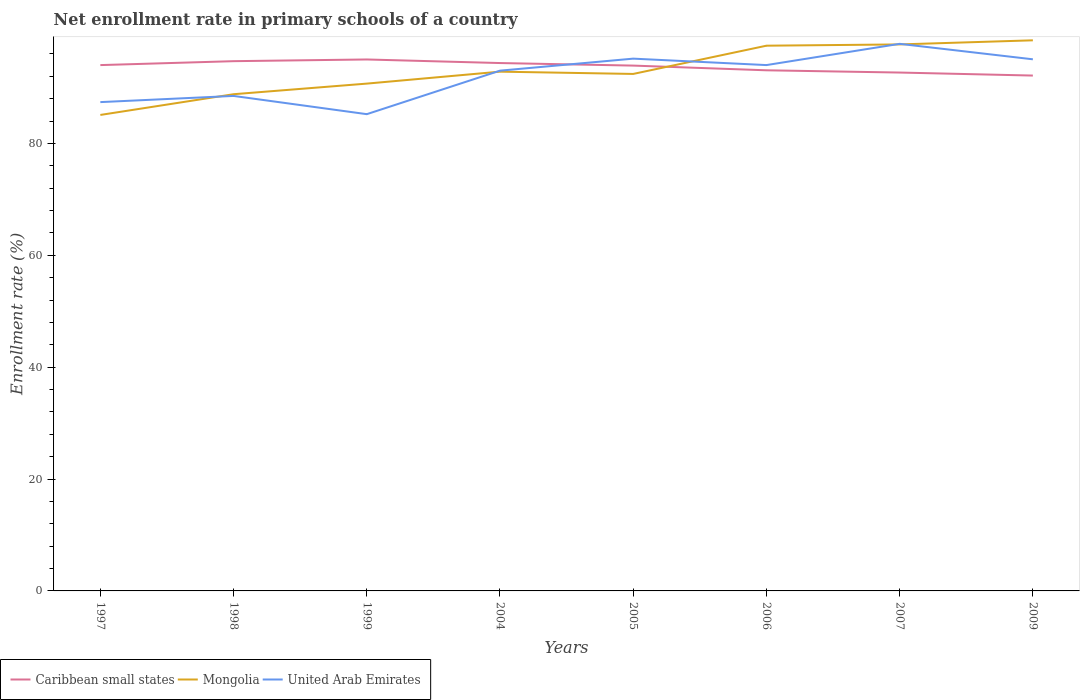How many different coloured lines are there?
Your answer should be very brief. 3. Is the number of lines equal to the number of legend labels?
Your response must be concise. Yes. Across all years, what is the maximum enrollment rate in primary schools in United Arab Emirates?
Provide a short and direct response. 85.24. What is the total enrollment rate in primary schools in Caribbean small states in the graph?
Offer a very short reply. 0.46. What is the difference between the highest and the second highest enrollment rate in primary schools in Mongolia?
Ensure brevity in your answer.  13.34. How many lines are there?
Your response must be concise. 3. How many years are there in the graph?
Offer a terse response. 8. Does the graph contain any zero values?
Your answer should be very brief. No. Does the graph contain grids?
Make the answer very short. No. How many legend labels are there?
Keep it short and to the point. 3. How are the legend labels stacked?
Give a very brief answer. Horizontal. What is the title of the graph?
Your answer should be compact. Net enrollment rate in primary schools of a country. What is the label or title of the Y-axis?
Your answer should be very brief. Enrollment rate (%). What is the Enrollment rate (%) of Caribbean small states in 1997?
Your response must be concise. 94.02. What is the Enrollment rate (%) in Mongolia in 1997?
Your answer should be compact. 85.1. What is the Enrollment rate (%) in United Arab Emirates in 1997?
Make the answer very short. 87.4. What is the Enrollment rate (%) in Caribbean small states in 1998?
Provide a succinct answer. 94.72. What is the Enrollment rate (%) in Mongolia in 1998?
Offer a terse response. 88.81. What is the Enrollment rate (%) of United Arab Emirates in 1998?
Give a very brief answer. 88.5. What is the Enrollment rate (%) in Caribbean small states in 1999?
Provide a succinct answer. 95.02. What is the Enrollment rate (%) of Mongolia in 1999?
Provide a short and direct response. 90.71. What is the Enrollment rate (%) in United Arab Emirates in 1999?
Keep it short and to the point. 85.24. What is the Enrollment rate (%) in Caribbean small states in 2004?
Offer a very short reply. 94.38. What is the Enrollment rate (%) in Mongolia in 2004?
Your response must be concise. 92.84. What is the Enrollment rate (%) of United Arab Emirates in 2004?
Ensure brevity in your answer.  93.02. What is the Enrollment rate (%) of Caribbean small states in 2005?
Your response must be concise. 93.93. What is the Enrollment rate (%) of Mongolia in 2005?
Provide a succinct answer. 92.44. What is the Enrollment rate (%) of United Arab Emirates in 2005?
Provide a succinct answer. 95.17. What is the Enrollment rate (%) of Caribbean small states in 2006?
Provide a short and direct response. 93.09. What is the Enrollment rate (%) in Mongolia in 2006?
Give a very brief answer. 97.49. What is the Enrollment rate (%) of United Arab Emirates in 2006?
Provide a short and direct response. 94.02. What is the Enrollment rate (%) in Caribbean small states in 2007?
Offer a terse response. 92.68. What is the Enrollment rate (%) of Mongolia in 2007?
Offer a terse response. 97.71. What is the Enrollment rate (%) of United Arab Emirates in 2007?
Ensure brevity in your answer.  97.82. What is the Enrollment rate (%) in Caribbean small states in 2009?
Make the answer very short. 92.14. What is the Enrollment rate (%) in Mongolia in 2009?
Make the answer very short. 98.45. What is the Enrollment rate (%) in United Arab Emirates in 2009?
Keep it short and to the point. 95.05. Across all years, what is the maximum Enrollment rate (%) in Caribbean small states?
Your answer should be compact. 95.02. Across all years, what is the maximum Enrollment rate (%) of Mongolia?
Keep it short and to the point. 98.45. Across all years, what is the maximum Enrollment rate (%) in United Arab Emirates?
Provide a succinct answer. 97.82. Across all years, what is the minimum Enrollment rate (%) of Caribbean small states?
Provide a succinct answer. 92.14. Across all years, what is the minimum Enrollment rate (%) in Mongolia?
Provide a short and direct response. 85.1. Across all years, what is the minimum Enrollment rate (%) in United Arab Emirates?
Provide a succinct answer. 85.24. What is the total Enrollment rate (%) of Caribbean small states in the graph?
Provide a short and direct response. 749.98. What is the total Enrollment rate (%) in Mongolia in the graph?
Your response must be concise. 743.54. What is the total Enrollment rate (%) in United Arab Emirates in the graph?
Make the answer very short. 736.22. What is the difference between the Enrollment rate (%) in Caribbean small states in 1997 and that in 1998?
Your answer should be very brief. -0.7. What is the difference between the Enrollment rate (%) of Mongolia in 1997 and that in 1998?
Your response must be concise. -3.71. What is the difference between the Enrollment rate (%) in United Arab Emirates in 1997 and that in 1998?
Your answer should be very brief. -1.11. What is the difference between the Enrollment rate (%) of Caribbean small states in 1997 and that in 1999?
Your answer should be very brief. -1. What is the difference between the Enrollment rate (%) in Mongolia in 1997 and that in 1999?
Make the answer very short. -5.6. What is the difference between the Enrollment rate (%) in United Arab Emirates in 1997 and that in 1999?
Provide a succinct answer. 2.16. What is the difference between the Enrollment rate (%) in Caribbean small states in 1997 and that in 2004?
Provide a succinct answer. -0.37. What is the difference between the Enrollment rate (%) in Mongolia in 1997 and that in 2004?
Offer a terse response. -7.74. What is the difference between the Enrollment rate (%) in United Arab Emirates in 1997 and that in 2004?
Your answer should be very brief. -5.62. What is the difference between the Enrollment rate (%) in Caribbean small states in 1997 and that in 2005?
Offer a very short reply. 0.09. What is the difference between the Enrollment rate (%) in Mongolia in 1997 and that in 2005?
Keep it short and to the point. -7.33. What is the difference between the Enrollment rate (%) of United Arab Emirates in 1997 and that in 2005?
Your answer should be compact. -7.77. What is the difference between the Enrollment rate (%) of Caribbean small states in 1997 and that in 2006?
Your answer should be compact. 0.93. What is the difference between the Enrollment rate (%) in Mongolia in 1997 and that in 2006?
Your answer should be compact. -12.38. What is the difference between the Enrollment rate (%) of United Arab Emirates in 1997 and that in 2006?
Give a very brief answer. -6.62. What is the difference between the Enrollment rate (%) in Caribbean small states in 1997 and that in 2007?
Provide a succinct answer. 1.33. What is the difference between the Enrollment rate (%) of Mongolia in 1997 and that in 2007?
Make the answer very short. -12.61. What is the difference between the Enrollment rate (%) of United Arab Emirates in 1997 and that in 2007?
Keep it short and to the point. -10.42. What is the difference between the Enrollment rate (%) of Caribbean small states in 1997 and that in 2009?
Provide a succinct answer. 1.87. What is the difference between the Enrollment rate (%) in Mongolia in 1997 and that in 2009?
Ensure brevity in your answer.  -13.34. What is the difference between the Enrollment rate (%) in United Arab Emirates in 1997 and that in 2009?
Give a very brief answer. -7.65. What is the difference between the Enrollment rate (%) in Caribbean small states in 1998 and that in 1999?
Your answer should be very brief. -0.3. What is the difference between the Enrollment rate (%) in Mongolia in 1998 and that in 1999?
Offer a very short reply. -1.9. What is the difference between the Enrollment rate (%) in United Arab Emirates in 1998 and that in 1999?
Ensure brevity in your answer.  3.26. What is the difference between the Enrollment rate (%) in Caribbean small states in 1998 and that in 2004?
Provide a succinct answer. 0.34. What is the difference between the Enrollment rate (%) in Mongolia in 1998 and that in 2004?
Ensure brevity in your answer.  -4.03. What is the difference between the Enrollment rate (%) of United Arab Emirates in 1998 and that in 2004?
Keep it short and to the point. -4.52. What is the difference between the Enrollment rate (%) in Caribbean small states in 1998 and that in 2005?
Your answer should be very brief. 0.79. What is the difference between the Enrollment rate (%) of Mongolia in 1998 and that in 2005?
Your answer should be very brief. -3.63. What is the difference between the Enrollment rate (%) of United Arab Emirates in 1998 and that in 2005?
Your response must be concise. -6.67. What is the difference between the Enrollment rate (%) of Caribbean small states in 1998 and that in 2006?
Provide a succinct answer. 1.63. What is the difference between the Enrollment rate (%) in Mongolia in 1998 and that in 2006?
Keep it short and to the point. -8.68. What is the difference between the Enrollment rate (%) in United Arab Emirates in 1998 and that in 2006?
Ensure brevity in your answer.  -5.52. What is the difference between the Enrollment rate (%) of Caribbean small states in 1998 and that in 2007?
Your response must be concise. 2.04. What is the difference between the Enrollment rate (%) of Mongolia in 1998 and that in 2007?
Make the answer very short. -8.9. What is the difference between the Enrollment rate (%) in United Arab Emirates in 1998 and that in 2007?
Keep it short and to the point. -9.31. What is the difference between the Enrollment rate (%) in Caribbean small states in 1998 and that in 2009?
Make the answer very short. 2.57. What is the difference between the Enrollment rate (%) of Mongolia in 1998 and that in 2009?
Offer a very short reply. -9.64. What is the difference between the Enrollment rate (%) in United Arab Emirates in 1998 and that in 2009?
Provide a succinct answer. -6.55. What is the difference between the Enrollment rate (%) in Caribbean small states in 1999 and that in 2004?
Offer a very short reply. 0.64. What is the difference between the Enrollment rate (%) of Mongolia in 1999 and that in 2004?
Your response must be concise. -2.14. What is the difference between the Enrollment rate (%) in United Arab Emirates in 1999 and that in 2004?
Give a very brief answer. -7.78. What is the difference between the Enrollment rate (%) in Caribbean small states in 1999 and that in 2005?
Offer a terse response. 1.1. What is the difference between the Enrollment rate (%) in Mongolia in 1999 and that in 2005?
Provide a short and direct response. -1.73. What is the difference between the Enrollment rate (%) in United Arab Emirates in 1999 and that in 2005?
Your answer should be very brief. -9.93. What is the difference between the Enrollment rate (%) in Caribbean small states in 1999 and that in 2006?
Provide a short and direct response. 1.94. What is the difference between the Enrollment rate (%) in Mongolia in 1999 and that in 2006?
Your response must be concise. -6.78. What is the difference between the Enrollment rate (%) of United Arab Emirates in 1999 and that in 2006?
Provide a succinct answer. -8.78. What is the difference between the Enrollment rate (%) of Caribbean small states in 1999 and that in 2007?
Give a very brief answer. 2.34. What is the difference between the Enrollment rate (%) in Mongolia in 1999 and that in 2007?
Your answer should be very brief. -7.01. What is the difference between the Enrollment rate (%) in United Arab Emirates in 1999 and that in 2007?
Your response must be concise. -12.58. What is the difference between the Enrollment rate (%) of Caribbean small states in 1999 and that in 2009?
Provide a succinct answer. 2.88. What is the difference between the Enrollment rate (%) in Mongolia in 1999 and that in 2009?
Make the answer very short. -7.74. What is the difference between the Enrollment rate (%) of United Arab Emirates in 1999 and that in 2009?
Ensure brevity in your answer.  -9.81. What is the difference between the Enrollment rate (%) in Caribbean small states in 2004 and that in 2005?
Offer a very short reply. 0.46. What is the difference between the Enrollment rate (%) in Mongolia in 2004 and that in 2005?
Offer a terse response. 0.41. What is the difference between the Enrollment rate (%) of United Arab Emirates in 2004 and that in 2005?
Your response must be concise. -2.15. What is the difference between the Enrollment rate (%) in Caribbean small states in 2004 and that in 2006?
Your answer should be very brief. 1.3. What is the difference between the Enrollment rate (%) in Mongolia in 2004 and that in 2006?
Provide a succinct answer. -4.64. What is the difference between the Enrollment rate (%) of United Arab Emirates in 2004 and that in 2006?
Your answer should be compact. -1. What is the difference between the Enrollment rate (%) of Caribbean small states in 2004 and that in 2007?
Ensure brevity in your answer.  1.7. What is the difference between the Enrollment rate (%) in Mongolia in 2004 and that in 2007?
Your answer should be very brief. -4.87. What is the difference between the Enrollment rate (%) in United Arab Emirates in 2004 and that in 2007?
Give a very brief answer. -4.8. What is the difference between the Enrollment rate (%) in Caribbean small states in 2004 and that in 2009?
Ensure brevity in your answer.  2.24. What is the difference between the Enrollment rate (%) in Mongolia in 2004 and that in 2009?
Make the answer very short. -5.6. What is the difference between the Enrollment rate (%) in United Arab Emirates in 2004 and that in 2009?
Keep it short and to the point. -2.03. What is the difference between the Enrollment rate (%) of Caribbean small states in 2005 and that in 2006?
Your answer should be compact. 0.84. What is the difference between the Enrollment rate (%) of Mongolia in 2005 and that in 2006?
Make the answer very short. -5.05. What is the difference between the Enrollment rate (%) in United Arab Emirates in 2005 and that in 2006?
Your answer should be very brief. 1.15. What is the difference between the Enrollment rate (%) in Caribbean small states in 2005 and that in 2007?
Your response must be concise. 1.24. What is the difference between the Enrollment rate (%) of Mongolia in 2005 and that in 2007?
Provide a short and direct response. -5.28. What is the difference between the Enrollment rate (%) in United Arab Emirates in 2005 and that in 2007?
Provide a short and direct response. -2.65. What is the difference between the Enrollment rate (%) of Caribbean small states in 2005 and that in 2009?
Your response must be concise. 1.78. What is the difference between the Enrollment rate (%) of Mongolia in 2005 and that in 2009?
Your answer should be compact. -6.01. What is the difference between the Enrollment rate (%) of United Arab Emirates in 2005 and that in 2009?
Ensure brevity in your answer.  0.12. What is the difference between the Enrollment rate (%) of Caribbean small states in 2006 and that in 2007?
Offer a terse response. 0.4. What is the difference between the Enrollment rate (%) of Mongolia in 2006 and that in 2007?
Offer a terse response. -0.23. What is the difference between the Enrollment rate (%) in United Arab Emirates in 2006 and that in 2007?
Make the answer very short. -3.8. What is the difference between the Enrollment rate (%) of Caribbean small states in 2006 and that in 2009?
Your answer should be compact. 0.94. What is the difference between the Enrollment rate (%) in Mongolia in 2006 and that in 2009?
Provide a succinct answer. -0.96. What is the difference between the Enrollment rate (%) in United Arab Emirates in 2006 and that in 2009?
Your answer should be compact. -1.03. What is the difference between the Enrollment rate (%) of Caribbean small states in 2007 and that in 2009?
Offer a terse response. 0.54. What is the difference between the Enrollment rate (%) of Mongolia in 2007 and that in 2009?
Provide a succinct answer. -0.73. What is the difference between the Enrollment rate (%) of United Arab Emirates in 2007 and that in 2009?
Your answer should be compact. 2.77. What is the difference between the Enrollment rate (%) in Caribbean small states in 1997 and the Enrollment rate (%) in Mongolia in 1998?
Provide a short and direct response. 5.21. What is the difference between the Enrollment rate (%) in Caribbean small states in 1997 and the Enrollment rate (%) in United Arab Emirates in 1998?
Make the answer very short. 5.51. What is the difference between the Enrollment rate (%) of Mongolia in 1997 and the Enrollment rate (%) of United Arab Emirates in 1998?
Provide a succinct answer. -3.4. What is the difference between the Enrollment rate (%) of Caribbean small states in 1997 and the Enrollment rate (%) of Mongolia in 1999?
Your response must be concise. 3.31. What is the difference between the Enrollment rate (%) of Caribbean small states in 1997 and the Enrollment rate (%) of United Arab Emirates in 1999?
Your answer should be very brief. 8.77. What is the difference between the Enrollment rate (%) in Mongolia in 1997 and the Enrollment rate (%) in United Arab Emirates in 1999?
Ensure brevity in your answer.  -0.14. What is the difference between the Enrollment rate (%) of Caribbean small states in 1997 and the Enrollment rate (%) of Mongolia in 2004?
Keep it short and to the point. 1.17. What is the difference between the Enrollment rate (%) of Mongolia in 1997 and the Enrollment rate (%) of United Arab Emirates in 2004?
Your response must be concise. -7.92. What is the difference between the Enrollment rate (%) in Caribbean small states in 1997 and the Enrollment rate (%) in Mongolia in 2005?
Ensure brevity in your answer.  1.58. What is the difference between the Enrollment rate (%) of Caribbean small states in 1997 and the Enrollment rate (%) of United Arab Emirates in 2005?
Provide a succinct answer. -1.15. What is the difference between the Enrollment rate (%) of Mongolia in 1997 and the Enrollment rate (%) of United Arab Emirates in 2005?
Give a very brief answer. -10.07. What is the difference between the Enrollment rate (%) in Caribbean small states in 1997 and the Enrollment rate (%) in Mongolia in 2006?
Your answer should be compact. -3.47. What is the difference between the Enrollment rate (%) of Caribbean small states in 1997 and the Enrollment rate (%) of United Arab Emirates in 2006?
Ensure brevity in your answer.  -0. What is the difference between the Enrollment rate (%) of Mongolia in 1997 and the Enrollment rate (%) of United Arab Emirates in 2006?
Your answer should be compact. -8.92. What is the difference between the Enrollment rate (%) in Caribbean small states in 1997 and the Enrollment rate (%) in Mongolia in 2007?
Offer a terse response. -3.7. What is the difference between the Enrollment rate (%) in Caribbean small states in 1997 and the Enrollment rate (%) in United Arab Emirates in 2007?
Your answer should be very brief. -3.8. What is the difference between the Enrollment rate (%) in Mongolia in 1997 and the Enrollment rate (%) in United Arab Emirates in 2007?
Give a very brief answer. -12.71. What is the difference between the Enrollment rate (%) in Caribbean small states in 1997 and the Enrollment rate (%) in Mongolia in 2009?
Provide a short and direct response. -4.43. What is the difference between the Enrollment rate (%) in Caribbean small states in 1997 and the Enrollment rate (%) in United Arab Emirates in 2009?
Ensure brevity in your answer.  -1.03. What is the difference between the Enrollment rate (%) in Mongolia in 1997 and the Enrollment rate (%) in United Arab Emirates in 2009?
Offer a terse response. -9.95. What is the difference between the Enrollment rate (%) in Caribbean small states in 1998 and the Enrollment rate (%) in Mongolia in 1999?
Ensure brevity in your answer.  4.01. What is the difference between the Enrollment rate (%) in Caribbean small states in 1998 and the Enrollment rate (%) in United Arab Emirates in 1999?
Make the answer very short. 9.48. What is the difference between the Enrollment rate (%) in Mongolia in 1998 and the Enrollment rate (%) in United Arab Emirates in 1999?
Ensure brevity in your answer.  3.57. What is the difference between the Enrollment rate (%) of Caribbean small states in 1998 and the Enrollment rate (%) of Mongolia in 2004?
Your response must be concise. 1.87. What is the difference between the Enrollment rate (%) of Caribbean small states in 1998 and the Enrollment rate (%) of United Arab Emirates in 2004?
Your answer should be compact. 1.7. What is the difference between the Enrollment rate (%) in Mongolia in 1998 and the Enrollment rate (%) in United Arab Emirates in 2004?
Your answer should be very brief. -4.21. What is the difference between the Enrollment rate (%) in Caribbean small states in 1998 and the Enrollment rate (%) in Mongolia in 2005?
Your response must be concise. 2.28. What is the difference between the Enrollment rate (%) in Caribbean small states in 1998 and the Enrollment rate (%) in United Arab Emirates in 2005?
Offer a very short reply. -0.45. What is the difference between the Enrollment rate (%) in Mongolia in 1998 and the Enrollment rate (%) in United Arab Emirates in 2005?
Offer a terse response. -6.36. What is the difference between the Enrollment rate (%) of Caribbean small states in 1998 and the Enrollment rate (%) of Mongolia in 2006?
Provide a short and direct response. -2.77. What is the difference between the Enrollment rate (%) in Caribbean small states in 1998 and the Enrollment rate (%) in United Arab Emirates in 2006?
Provide a succinct answer. 0.7. What is the difference between the Enrollment rate (%) of Mongolia in 1998 and the Enrollment rate (%) of United Arab Emirates in 2006?
Provide a short and direct response. -5.21. What is the difference between the Enrollment rate (%) of Caribbean small states in 1998 and the Enrollment rate (%) of Mongolia in 2007?
Ensure brevity in your answer.  -2.99. What is the difference between the Enrollment rate (%) of Caribbean small states in 1998 and the Enrollment rate (%) of United Arab Emirates in 2007?
Keep it short and to the point. -3.1. What is the difference between the Enrollment rate (%) in Mongolia in 1998 and the Enrollment rate (%) in United Arab Emirates in 2007?
Offer a terse response. -9.01. What is the difference between the Enrollment rate (%) of Caribbean small states in 1998 and the Enrollment rate (%) of Mongolia in 2009?
Your response must be concise. -3.73. What is the difference between the Enrollment rate (%) of Caribbean small states in 1998 and the Enrollment rate (%) of United Arab Emirates in 2009?
Offer a terse response. -0.33. What is the difference between the Enrollment rate (%) of Mongolia in 1998 and the Enrollment rate (%) of United Arab Emirates in 2009?
Offer a very short reply. -6.24. What is the difference between the Enrollment rate (%) of Caribbean small states in 1999 and the Enrollment rate (%) of Mongolia in 2004?
Keep it short and to the point. 2.18. What is the difference between the Enrollment rate (%) in Caribbean small states in 1999 and the Enrollment rate (%) in United Arab Emirates in 2004?
Make the answer very short. 2. What is the difference between the Enrollment rate (%) in Mongolia in 1999 and the Enrollment rate (%) in United Arab Emirates in 2004?
Give a very brief answer. -2.32. What is the difference between the Enrollment rate (%) of Caribbean small states in 1999 and the Enrollment rate (%) of Mongolia in 2005?
Make the answer very short. 2.59. What is the difference between the Enrollment rate (%) of Caribbean small states in 1999 and the Enrollment rate (%) of United Arab Emirates in 2005?
Your response must be concise. -0.15. What is the difference between the Enrollment rate (%) of Mongolia in 1999 and the Enrollment rate (%) of United Arab Emirates in 2005?
Offer a very short reply. -4.46. What is the difference between the Enrollment rate (%) in Caribbean small states in 1999 and the Enrollment rate (%) in Mongolia in 2006?
Give a very brief answer. -2.46. What is the difference between the Enrollment rate (%) of Mongolia in 1999 and the Enrollment rate (%) of United Arab Emirates in 2006?
Offer a terse response. -3.31. What is the difference between the Enrollment rate (%) in Caribbean small states in 1999 and the Enrollment rate (%) in Mongolia in 2007?
Ensure brevity in your answer.  -2.69. What is the difference between the Enrollment rate (%) of Caribbean small states in 1999 and the Enrollment rate (%) of United Arab Emirates in 2007?
Ensure brevity in your answer.  -2.8. What is the difference between the Enrollment rate (%) of Mongolia in 1999 and the Enrollment rate (%) of United Arab Emirates in 2007?
Your answer should be very brief. -7.11. What is the difference between the Enrollment rate (%) in Caribbean small states in 1999 and the Enrollment rate (%) in Mongolia in 2009?
Your answer should be compact. -3.43. What is the difference between the Enrollment rate (%) in Caribbean small states in 1999 and the Enrollment rate (%) in United Arab Emirates in 2009?
Offer a terse response. -0.03. What is the difference between the Enrollment rate (%) in Mongolia in 1999 and the Enrollment rate (%) in United Arab Emirates in 2009?
Give a very brief answer. -4.34. What is the difference between the Enrollment rate (%) in Caribbean small states in 2004 and the Enrollment rate (%) in Mongolia in 2005?
Your response must be concise. 1.95. What is the difference between the Enrollment rate (%) of Caribbean small states in 2004 and the Enrollment rate (%) of United Arab Emirates in 2005?
Make the answer very short. -0.79. What is the difference between the Enrollment rate (%) of Mongolia in 2004 and the Enrollment rate (%) of United Arab Emirates in 2005?
Your answer should be compact. -2.33. What is the difference between the Enrollment rate (%) of Caribbean small states in 2004 and the Enrollment rate (%) of Mongolia in 2006?
Offer a terse response. -3.1. What is the difference between the Enrollment rate (%) in Caribbean small states in 2004 and the Enrollment rate (%) in United Arab Emirates in 2006?
Your response must be concise. 0.36. What is the difference between the Enrollment rate (%) in Mongolia in 2004 and the Enrollment rate (%) in United Arab Emirates in 2006?
Your answer should be compact. -1.18. What is the difference between the Enrollment rate (%) of Caribbean small states in 2004 and the Enrollment rate (%) of Mongolia in 2007?
Offer a terse response. -3.33. What is the difference between the Enrollment rate (%) in Caribbean small states in 2004 and the Enrollment rate (%) in United Arab Emirates in 2007?
Your answer should be compact. -3.43. What is the difference between the Enrollment rate (%) of Mongolia in 2004 and the Enrollment rate (%) of United Arab Emirates in 2007?
Provide a succinct answer. -4.97. What is the difference between the Enrollment rate (%) in Caribbean small states in 2004 and the Enrollment rate (%) in Mongolia in 2009?
Your response must be concise. -4.07. What is the difference between the Enrollment rate (%) of Caribbean small states in 2004 and the Enrollment rate (%) of United Arab Emirates in 2009?
Your answer should be compact. -0.67. What is the difference between the Enrollment rate (%) in Mongolia in 2004 and the Enrollment rate (%) in United Arab Emirates in 2009?
Your response must be concise. -2.21. What is the difference between the Enrollment rate (%) in Caribbean small states in 2005 and the Enrollment rate (%) in Mongolia in 2006?
Keep it short and to the point. -3.56. What is the difference between the Enrollment rate (%) of Caribbean small states in 2005 and the Enrollment rate (%) of United Arab Emirates in 2006?
Make the answer very short. -0.09. What is the difference between the Enrollment rate (%) of Mongolia in 2005 and the Enrollment rate (%) of United Arab Emirates in 2006?
Give a very brief answer. -1.58. What is the difference between the Enrollment rate (%) in Caribbean small states in 2005 and the Enrollment rate (%) in Mongolia in 2007?
Offer a terse response. -3.79. What is the difference between the Enrollment rate (%) of Caribbean small states in 2005 and the Enrollment rate (%) of United Arab Emirates in 2007?
Give a very brief answer. -3.89. What is the difference between the Enrollment rate (%) in Mongolia in 2005 and the Enrollment rate (%) in United Arab Emirates in 2007?
Offer a very short reply. -5.38. What is the difference between the Enrollment rate (%) of Caribbean small states in 2005 and the Enrollment rate (%) of Mongolia in 2009?
Provide a short and direct response. -4.52. What is the difference between the Enrollment rate (%) in Caribbean small states in 2005 and the Enrollment rate (%) in United Arab Emirates in 2009?
Your answer should be compact. -1.12. What is the difference between the Enrollment rate (%) of Mongolia in 2005 and the Enrollment rate (%) of United Arab Emirates in 2009?
Provide a succinct answer. -2.61. What is the difference between the Enrollment rate (%) of Caribbean small states in 2006 and the Enrollment rate (%) of Mongolia in 2007?
Your answer should be compact. -4.63. What is the difference between the Enrollment rate (%) in Caribbean small states in 2006 and the Enrollment rate (%) in United Arab Emirates in 2007?
Your answer should be very brief. -4.73. What is the difference between the Enrollment rate (%) in Mongolia in 2006 and the Enrollment rate (%) in United Arab Emirates in 2007?
Provide a short and direct response. -0.33. What is the difference between the Enrollment rate (%) of Caribbean small states in 2006 and the Enrollment rate (%) of Mongolia in 2009?
Make the answer very short. -5.36. What is the difference between the Enrollment rate (%) in Caribbean small states in 2006 and the Enrollment rate (%) in United Arab Emirates in 2009?
Offer a very short reply. -1.96. What is the difference between the Enrollment rate (%) in Mongolia in 2006 and the Enrollment rate (%) in United Arab Emirates in 2009?
Ensure brevity in your answer.  2.44. What is the difference between the Enrollment rate (%) in Caribbean small states in 2007 and the Enrollment rate (%) in Mongolia in 2009?
Give a very brief answer. -5.77. What is the difference between the Enrollment rate (%) of Caribbean small states in 2007 and the Enrollment rate (%) of United Arab Emirates in 2009?
Provide a short and direct response. -2.37. What is the difference between the Enrollment rate (%) of Mongolia in 2007 and the Enrollment rate (%) of United Arab Emirates in 2009?
Keep it short and to the point. 2.66. What is the average Enrollment rate (%) in Caribbean small states per year?
Give a very brief answer. 93.75. What is the average Enrollment rate (%) in Mongolia per year?
Provide a succinct answer. 92.94. What is the average Enrollment rate (%) of United Arab Emirates per year?
Your response must be concise. 92.03. In the year 1997, what is the difference between the Enrollment rate (%) of Caribbean small states and Enrollment rate (%) of Mongolia?
Your response must be concise. 8.91. In the year 1997, what is the difference between the Enrollment rate (%) in Caribbean small states and Enrollment rate (%) in United Arab Emirates?
Provide a succinct answer. 6.62. In the year 1997, what is the difference between the Enrollment rate (%) of Mongolia and Enrollment rate (%) of United Arab Emirates?
Ensure brevity in your answer.  -2.29. In the year 1998, what is the difference between the Enrollment rate (%) of Caribbean small states and Enrollment rate (%) of Mongolia?
Your answer should be compact. 5.91. In the year 1998, what is the difference between the Enrollment rate (%) in Caribbean small states and Enrollment rate (%) in United Arab Emirates?
Your answer should be compact. 6.21. In the year 1998, what is the difference between the Enrollment rate (%) of Mongolia and Enrollment rate (%) of United Arab Emirates?
Keep it short and to the point. 0.3. In the year 1999, what is the difference between the Enrollment rate (%) of Caribbean small states and Enrollment rate (%) of Mongolia?
Make the answer very short. 4.32. In the year 1999, what is the difference between the Enrollment rate (%) of Caribbean small states and Enrollment rate (%) of United Arab Emirates?
Provide a succinct answer. 9.78. In the year 1999, what is the difference between the Enrollment rate (%) of Mongolia and Enrollment rate (%) of United Arab Emirates?
Your response must be concise. 5.46. In the year 2004, what is the difference between the Enrollment rate (%) of Caribbean small states and Enrollment rate (%) of Mongolia?
Provide a succinct answer. 1.54. In the year 2004, what is the difference between the Enrollment rate (%) in Caribbean small states and Enrollment rate (%) in United Arab Emirates?
Your response must be concise. 1.36. In the year 2004, what is the difference between the Enrollment rate (%) in Mongolia and Enrollment rate (%) in United Arab Emirates?
Ensure brevity in your answer.  -0.18. In the year 2005, what is the difference between the Enrollment rate (%) of Caribbean small states and Enrollment rate (%) of Mongolia?
Make the answer very short. 1.49. In the year 2005, what is the difference between the Enrollment rate (%) of Caribbean small states and Enrollment rate (%) of United Arab Emirates?
Your response must be concise. -1.24. In the year 2005, what is the difference between the Enrollment rate (%) in Mongolia and Enrollment rate (%) in United Arab Emirates?
Your answer should be compact. -2.73. In the year 2006, what is the difference between the Enrollment rate (%) of Caribbean small states and Enrollment rate (%) of Mongolia?
Give a very brief answer. -4.4. In the year 2006, what is the difference between the Enrollment rate (%) in Caribbean small states and Enrollment rate (%) in United Arab Emirates?
Make the answer very short. -0.93. In the year 2006, what is the difference between the Enrollment rate (%) of Mongolia and Enrollment rate (%) of United Arab Emirates?
Keep it short and to the point. 3.47. In the year 2007, what is the difference between the Enrollment rate (%) of Caribbean small states and Enrollment rate (%) of Mongolia?
Offer a very short reply. -5.03. In the year 2007, what is the difference between the Enrollment rate (%) in Caribbean small states and Enrollment rate (%) in United Arab Emirates?
Offer a terse response. -5.13. In the year 2007, what is the difference between the Enrollment rate (%) of Mongolia and Enrollment rate (%) of United Arab Emirates?
Make the answer very short. -0.1. In the year 2009, what is the difference between the Enrollment rate (%) of Caribbean small states and Enrollment rate (%) of Mongolia?
Provide a succinct answer. -6.3. In the year 2009, what is the difference between the Enrollment rate (%) of Caribbean small states and Enrollment rate (%) of United Arab Emirates?
Your answer should be very brief. -2.91. In the year 2009, what is the difference between the Enrollment rate (%) of Mongolia and Enrollment rate (%) of United Arab Emirates?
Your response must be concise. 3.4. What is the ratio of the Enrollment rate (%) of Mongolia in 1997 to that in 1998?
Your answer should be very brief. 0.96. What is the ratio of the Enrollment rate (%) in United Arab Emirates in 1997 to that in 1998?
Offer a terse response. 0.99. What is the ratio of the Enrollment rate (%) of Caribbean small states in 1997 to that in 1999?
Offer a terse response. 0.99. What is the ratio of the Enrollment rate (%) in Mongolia in 1997 to that in 1999?
Provide a succinct answer. 0.94. What is the ratio of the Enrollment rate (%) of United Arab Emirates in 1997 to that in 1999?
Provide a short and direct response. 1.03. What is the ratio of the Enrollment rate (%) in Mongolia in 1997 to that in 2004?
Your answer should be very brief. 0.92. What is the ratio of the Enrollment rate (%) of United Arab Emirates in 1997 to that in 2004?
Your response must be concise. 0.94. What is the ratio of the Enrollment rate (%) of Caribbean small states in 1997 to that in 2005?
Offer a terse response. 1. What is the ratio of the Enrollment rate (%) in Mongolia in 1997 to that in 2005?
Your response must be concise. 0.92. What is the ratio of the Enrollment rate (%) of United Arab Emirates in 1997 to that in 2005?
Make the answer very short. 0.92. What is the ratio of the Enrollment rate (%) in Mongolia in 1997 to that in 2006?
Your answer should be very brief. 0.87. What is the ratio of the Enrollment rate (%) of United Arab Emirates in 1997 to that in 2006?
Provide a succinct answer. 0.93. What is the ratio of the Enrollment rate (%) in Caribbean small states in 1997 to that in 2007?
Your answer should be very brief. 1.01. What is the ratio of the Enrollment rate (%) in Mongolia in 1997 to that in 2007?
Provide a short and direct response. 0.87. What is the ratio of the Enrollment rate (%) of United Arab Emirates in 1997 to that in 2007?
Provide a succinct answer. 0.89. What is the ratio of the Enrollment rate (%) in Caribbean small states in 1997 to that in 2009?
Keep it short and to the point. 1.02. What is the ratio of the Enrollment rate (%) in Mongolia in 1997 to that in 2009?
Your answer should be very brief. 0.86. What is the ratio of the Enrollment rate (%) of United Arab Emirates in 1997 to that in 2009?
Keep it short and to the point. 0.92. What is the ratio of the Enrollment rate (%) of Caribbean small states in 1998 to that in 1999?
Ensure brevity in your answer.  1. What is the ratio of the Enrollment rate (%) in Mongolia in 1998 to that in 1999?
Offer a very short reply. 0.98. What is the ratio of the Enrollment rate (%) of United Arab Emirates in 1998 to that in 1999?
Give a very brief answer. 1.04. What is the ratio of the Enrollment rate (%) in Mongolia in 1998 to that in 2004?
Ensure brevity in your answer.  0.96. What is the ratio of the Enrollment rate (%) in United Arab Emirates in 1998 to that in 2004?
Give a very brief answer. 0.95. What is the ratio of the Enrollment rate (%) in Caribbean small states in 1998 to that in 2005?
Offer a very short reply. 1.01. What is the ratio of the Enrollment rate (%) in Mongolia in 1998 to that in 2005?
Provide a succinct answer. 0.96. What is the ratio of the Enrollment rate (%) in Caribbean small states in 1998 to that in 2006?
Your answer should be very brief. 1.02. What is the ratio of the Enrollment rate (%) in Mongolia in 1998 to that in 2006?
Make the answer very short. 0.91. What is the ratio of the Enrollment rate (%) of United Arab Emirates in 1998 to that in 2006?
Offer a terse response. 0.94. What is the ratio of the Enrollment rate (%) of Mongolia in 1998 to that in 2007?
Provide a short and direct response. 0.91. What is the ratio of the Enrollment rate (%) in United Arab Emirates in 1998 to that in 2007?
Your response must be concise. 0.9. What is the ratio of the Enrollment rate (%) of Caribbean small states in 1998 to that in 2009?
Offer a very short reply. 1.03. What is the ratio of the Enrollment rate (%) of Mongolia in 1998 to that in 2009?
Make the answer very short. 0.9. What is the ratio of the Enrollment rate (%) of United Arab Emirates in 1998 to that in 2009?
Give a very brief answer. 0.93. What is the ratio of the Enrollment rate (%) of Caribbean small states in 1999 to that in 2004?
Your response must be concise. 1.01. What is the ratio of the Enrollment rate (%) of Mongolia in 1999 to that in 2004?
Your answer should be very brief. 0.98. What is the ratio of the Enrollment rate (%) in United Arab Emirates in 1999 to that in 2004?
Your answer should be very brief. 0.92. What is the ratio of the Enrollment rate (%) in Caribbean small states in 1999 to that in 2005?
Offer a very short reply. 1.01. What is the ratio of the Enrollment rate (%) of Mongolia in 1999 to that in 2005?
Make the answer very short. 0.98. What is the ratio of the Enrollment rate (%) of United Arab Emirates in 1999 to that in 2005?
Make the answer very short. 0.9. What is the ratio of the Enrollment rate (%) in Caribbean small states in 1999 to that in 2006?
Your response must be concise. 1.02. What is the ratio of the Enrollment rate (%) of Mongolia in 1999 to that in 2006?
Your response must be concise. 0.93. What is the ratio of the Enrollment rate (%) of United Arab Emirates in 1999 to that in 2006?
Offer a terse response. 0.91. What is the ratio of the Enrollment rate (%) of Caribbean small states in 1999 to that in 2007?
Your answer should be compact. 1.03. What is the ratio of the Enrollment rate (%) of Mongolia in 1999 to that in 2007?
Give a very brief answer. 0.93. What is the ratio of the Enrollment rate (%) in United Arab Emirates in 1999 to that in 2007?
Ensure brevity in your answer.  0.87. What is the ratio of the Enrollment rate (%) in Caribbean small states in 1999 to that in 2009?
Give a very brief answer. 1.03. What is the ratio of the Enrollment rate (%) in Mongolia in 1999 to that in 2009?
Provide a short and direct response. 0.92. What is the ratio of the Enrollment rate (%) in United Arab Emirates in 1999 to that in 2009?
Your response must be concise. 0.9. What is the ratio of the Enrollment rate (%) of Mongolia in 2004 to that in 2005?
Your response must be concise. 1. What is the ratio of the Enrollment rate (%) of United Arab Emirates in 2004 to that in 2005?
Your response must be concise. 0.98. What is the ratio of the Enrollment rate (%) in Caribbean small states in 2004 to that in 2006?
Keep it short and to the point. 1.01. What is the ratio of the Enrollment rate (%) of United Arab Emirates in 2004 to that in 2006?
Your answer should be compact. 0.99. What is the ratio of the Enrollment rate (%) in Caribbean small states in 2004 to that in 2007?
Provide a succinct answer. 1.02. What is the ratio of the Enrollment rate (%) of Mongolia in 2004 to that in 2007?
Offer a very short reply. 0.95. What is the ratio of the Enrollment rate (%) in United Arab Emirates in 2004 to that in 2007?
Offer a very short reply. 0.95. What is the ratio of the Enrollment rate (%) in Caribbean small states in 2004 to that in 2009?
Offer a very short reply. 1.02. What is the ratio of the Enrollment rate (%) of Mongolia in 2004 to that in 2009?
Your answer should be compact. 0.94. What is the ratio of the Enrollment rate (%) in United Arab Emirates in 2004 to that in 2009?
Offer a terse response. 0.98. What is the ratio of the Enrollment rate (%) of Caribbean small states in 2005 to that in 2006?
Give a very brief answer. 1.01. What is the ratio of the Enrollment rate (%) in Mongolia in 2005 to that in 2006?
Your response must be concise. 0.95. What is the ratio of the Enrollment rate (%) of United Arab Emirates in 2005 to that in 2006?
Give a very brief answer. 1.01. What is the ratio of the Enrollment rate (%) in Caribbean small states in 2005 to that in 2007?
Keep it short and to the point. 1.01. What is the ratio of the Enrollment rate (%) in Mongolia in 2005 to that in 2007?
Provide a short and direct response. 0.95. What is the ratio of the Enrollment rate (%) of United Arab Emirates in 2005 to that in 2007?
Your answer should be compact. 0.97. What is the ratio of the Enrollment rate (%) in Caribbean small states in 2005 to that in 2009?
Make the answer very short. 1.02. What is the ratio of the Enrollment rate (%) in Mongolia in 2005 to that in 2009?
Ensure brevity in your answer.  0.94. What is the ratio of the Enrollment rate (%) of United Arab Emirates in 2006 to that in 2007?
Your answer should be very brief. 0.96. What is the ratio of the Enrollment rate (%) in Caribbean small states in 2006 to that in 2009?
Provide a short and direct response. 1.01. What is the ratio of the Enrollment rate (%) in Mongolia in 2006 to that in 2009?
Your answer should be very brief. 0.99. What is the ratio of the Enrollment rate (%) of United Arab Emirates in 2006 to that in 2009?
Your answer should be very brief. 0.99. What is the ratio of the Enrollment rate (%) in Caribbean small states in 2007 to that in 2009?
Ensure brevity in your answer.  1.01. What is the ratio of the Enrollment rate (%) in Mongolia in 2007 to that in 2009?
Keep it short and to the point. 0.99. What is the ratio of the Enrollment rate (%) of United Arab Emirates in 2007 to that in 2009?
Provide a short and direct response. 1.03. What is the difference between the highest and the second highest Enrollment rate (%) in Caribbean small states?
Provide a succinct answer. 0.3. What is the difference between the highest and the second highest Enrollment rate (%) in Mongolia?
Keep it short and to the point. 0.73. What is the difference between the highest and the second highest Enrollment rate (%) of United Arab Emirates?
Your response must be concise. 2.65. What is the difference between the highest and the lowest Enrollment rate (%) of Caribbean small states?
Offer a terse response. 2.88. What is the difference between the highest and the lowest Enrollment rate (%) of Mongolia?
Offer a terse response. 13.34. What is the difference between the highest and the lowest Enrollment rate (%) in United Arab Emirates?
Make the answer very short. 12.58. 